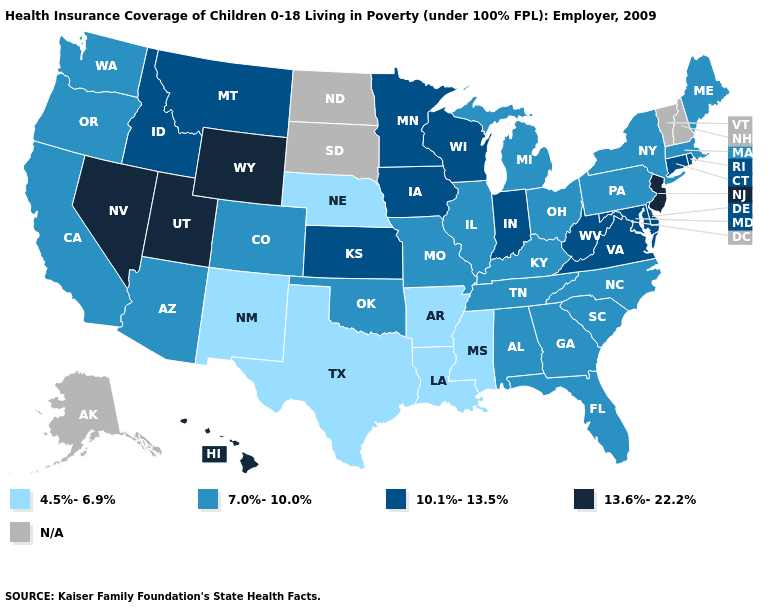Name the states that have a value in the range N/A?
Concise answer only. Alaska, New Hampshire, North Dakota, South Dakota, Vermont. Does the map have missing data?
Quick response, please. Yes. What is the value of Tennessee?
Concise answer only. 7.0%-10.0%. What is the value of Minnesota?
Give a very brief answer. 10.1%-13.5%. Name the states that have a value in the range 4.5%-6.9%?
Write a very short answer. Arkansas, Louisiana, Mississippi, Nebraska, New Mexico, Texas. Name the states that have a value in the range 7.0%-10.0%?
Concise answer only. Alabama, Arizona, California, Colorado, Florida, Georgia, Illinois, Kentucky, Maine, Massachusetts, Michigan, Missouri, New York, North Carolina, Ohio, Oklahoma, Oregon, Pennsylvania, South Carolina, Tennessee, Washington. Name the states that have a value in the range 13.6%-22.2%?
Write a very short answer. Hawaii, Nevada, New Jersey, Utah, Wyoming. Among the states that border New York , which have the lowest value?
Write a very short answer. Massachusetts, Pennsylvania. What is the value of Vermont?
Keep it brief. N/A. What is the value of Alaska?
Quick response, please. N/A. How many symbols are there in the legend?
Concise answer only. 5. Does the map have missing data?
Give a very brief answer. Yes. Which states hav the highest value in the West?
Be succinct. Hawaii, Nevada, Utah, Wyoming. Does Illinois have the highest value in the USA?
Give a very brief answer. No. 